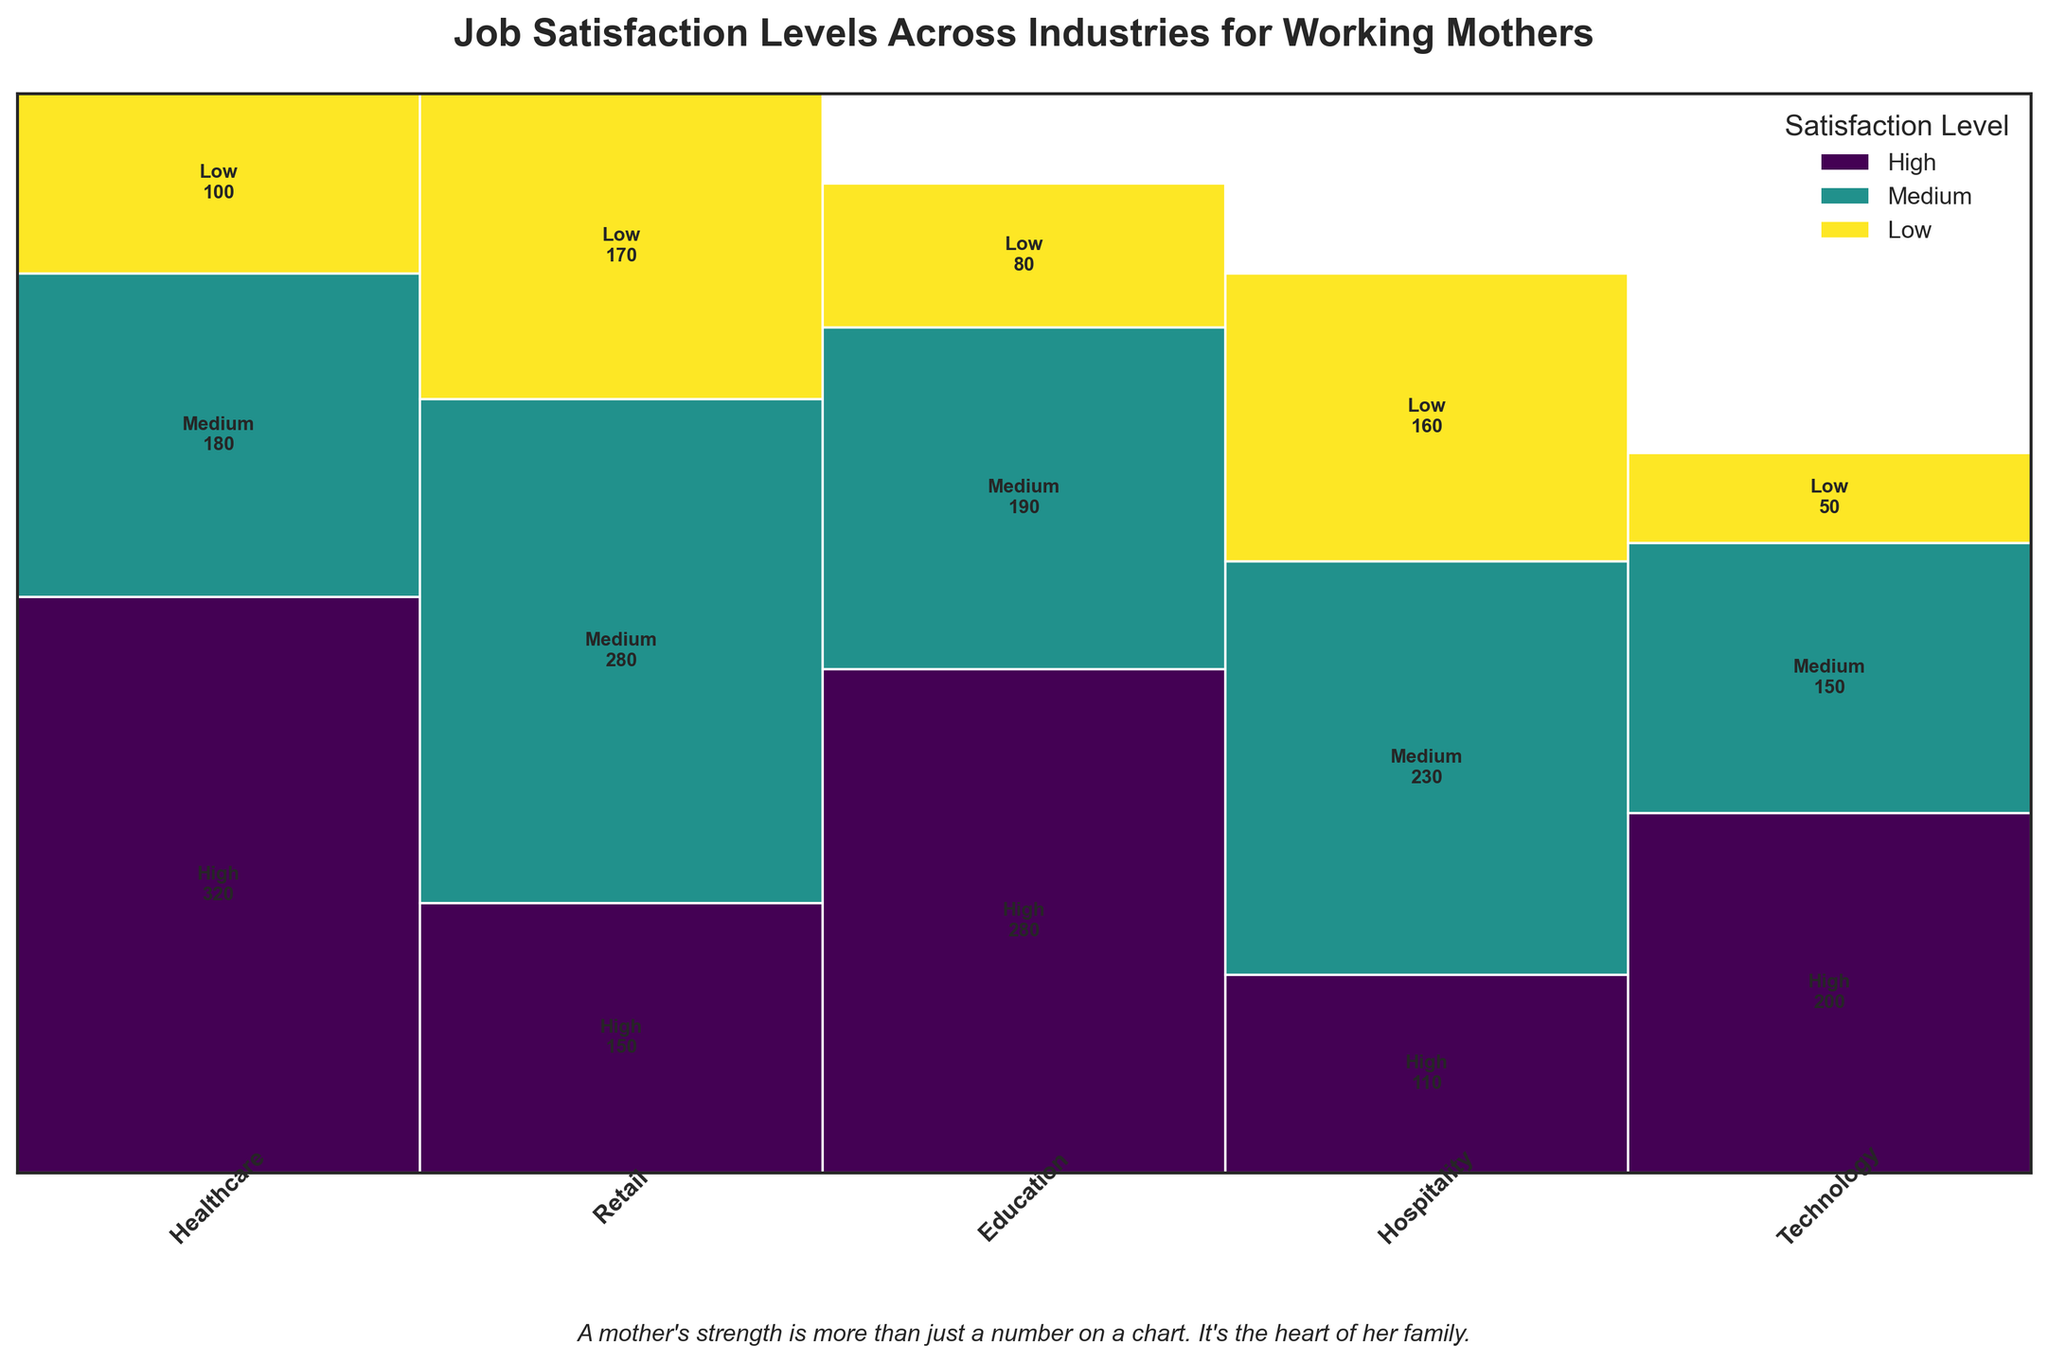What is the title of the figure? The title is located at the top of the figure. It should provide an overall description of what the figure is about.
Answer: Job Satisfaction Levels Across Industries for Working Mothers Which satisfaction level has the highest number of working mothers in the Healthcare industry? Look for the Healthcare segment and identify the color that corresponds to the highest satisfaction level, then check the number annotated.
Answer: High Which industry has the highest overall number of working mothers? Sum up the number of working mothers in each satisfaction level for each industry and identify the tallest bar.
Answer: Healthcare How many working mothers in the Retail industry have medium satisfaction? Identify the medium satisfaction segment for the Retail industry, which is represented by a specific color, and read the corresponding number.
Answer: 280 Compare the number of working mothers with low satisfaction in Technology and Hospitality. Which industry has more? Look at the segments for low satisfaction in both Technology and Hospitality, and compare the annotated numbers.
Answer: Hospitality What is the total number of working mothers in the Education industry? Add up the numbers for high, medium, and low satisfaction in the Education industry. Explanation: 280 (High) + 190 (Medium) + 80 (Low) = 550
Answer: 550 Which industry has the lowest number of working mothers with high satisfaction? Examine the segments corresponding to high satisfaction across all industries and identify the smallest number.
Answer: Hospitality How many more working mothers have medium satisfaction in Healthcare compared to Technology? Subtract the number of working mothers with medium satisfaction in Technology from that in Healthcare. Explanation: 180 (Healthcare) - 150 (Technology) = 30
Answer: 30 Among the listed industries, which one has approximately equal numbers of working mothers in both medium and low satisfaction levels? Check each industry to compare the annotated numbers for medium and low satisfaction levels and identify if there is an approximate match.
Answer: Retail 